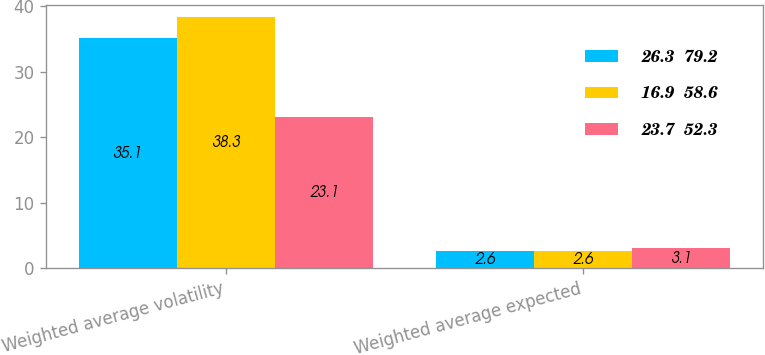Convert chart. <chart><loc_0><loc_0><loc_500><loc_500><stacked_bar_chart><ecel><fcel>Weighted average volatility<fcel>Weighted average expected<nl><fcel>26.3  79.2<fcel>35.1<fcel>2.6<nl><fcel>16.9  58.6<fcel>38.3<fcel>2.6<nl><fcel>23.7  52.3<fcel>23.1<fcel>3.1<nl></chart> 